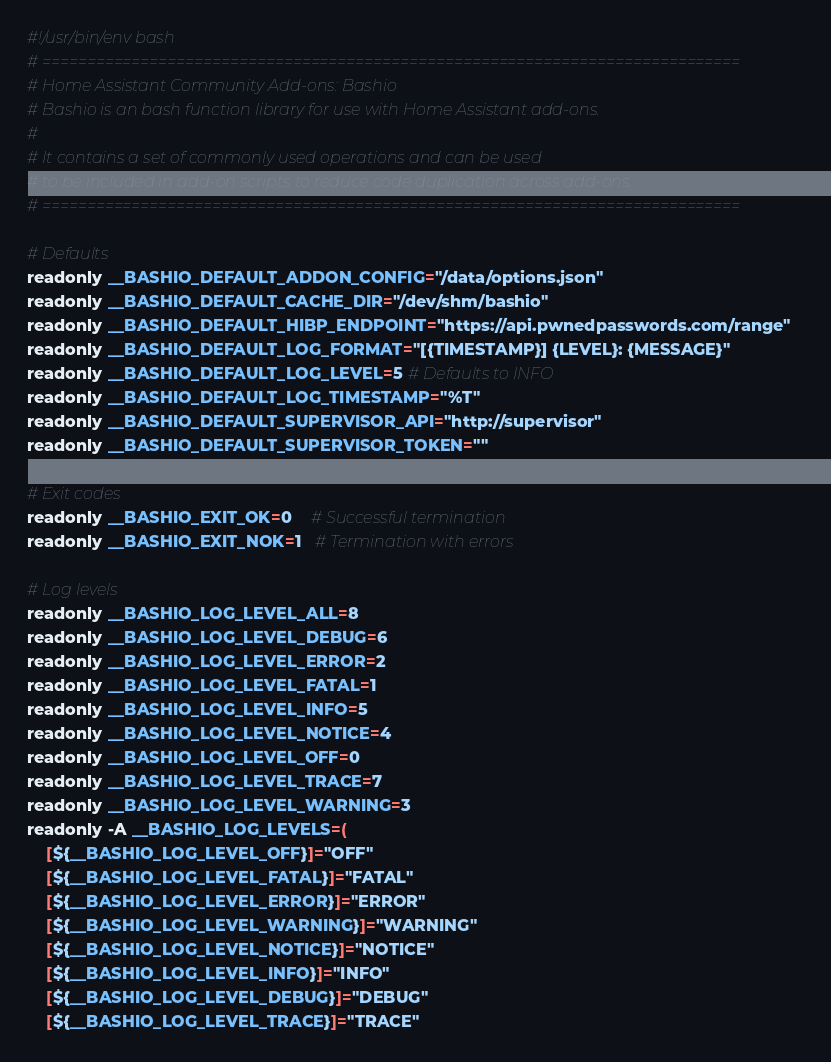<code> <loc_0><loc_0><loc_500><loc_500><_Bash_>#!/usr/bin/env bash
# ==============================================================================
# Home Assistant Community Add-ons: Bashio
# Bashio is an bash function library for use with Home Assistant add-ons.
#
# It contains a set of commonly used operations and can be used
# to be included in add-on scripts to reduce code duplication across add-ons.
# ==============================================================================

# Defaults
readonly __BASHIO_DEFAULT_ADDON_CONFIG="/data/options.json"
readonly __BASHIO_DEFAULT_CACHE_DIR="/dev/shm/bashio"
readonly __BASHIO_DEFAULT_HIBP_ENDPOINT="https://api.pwnedpasswords.com/range"
readonly __BASHIO_DEFAULT_LOG_FORMAT="[{TIMESTAMP}] {LEVEL}: {MESSAGE}"
readonly __BASHIO_DEFAULT_LOG_LEVEL=5 # Defaults to INFO
readonly __BASHIO_DEFAULT_LOG_TIMESTAMP="%T"
readonly __BASHIO_DEFAULT_SUPERVISOR_API="http://supervisor"
readonly __BASHIO_DEFAULT_SUPERVISOR_TOKEN=""

# Exit codes
readonly __BASHIO_EXIT_OK=0    # Successful termination
readonly __BASHIO_EXIT_NOK=1   # Termination with errors

# Log levels
readonly __BASHIO_LOG_LEVEL_ALL=8
readonly __BASHIO_LOG_LEVEL_DEBUG=6
readonly __BASHIO_LOG_LEVEL_ERROR=2
readonly __BASHIO_LOG_LEVEL_FATAL=1
readonly __BASHIO_LOG_LEVEL_INFO=5
readonly __BASHIO_LOG_LEVEL_NOTICE=4
readonly __BASHIO_LOG_LEVEL_OFF=0
readonly __BASHIO_LOG_LEVEL_TRACE=7
readonly __BASHIO_LOG_LEVEL_WARNING=3
readonly -A __BASHIO_LOG_LEVELS=(
    [${__BASHIO_LOG_LEVEL_OFF}]="OFF"
    [${__BASHIO_LOG_LEVEL_FATAL}]="FATAL"
    [${__BASHIO_LOG_LEVEL_ERROR}]="ERROR"
    [${__BASHIO_LOG_LEVEL_WARNING}]="WARNING"
    [${__BASHIO_LOG_LEVEL_NOTICE}]="NOTICE"
    [${__BASHIO_LOG_LEVEL_INFO}]="INFO"
    [${__BASHIO_LOG_LEVEL_DEBUG}]="DEBUG"
    [${__BASHIO_LOG_LEVEL_TRACE}]="TRACE"</code> 